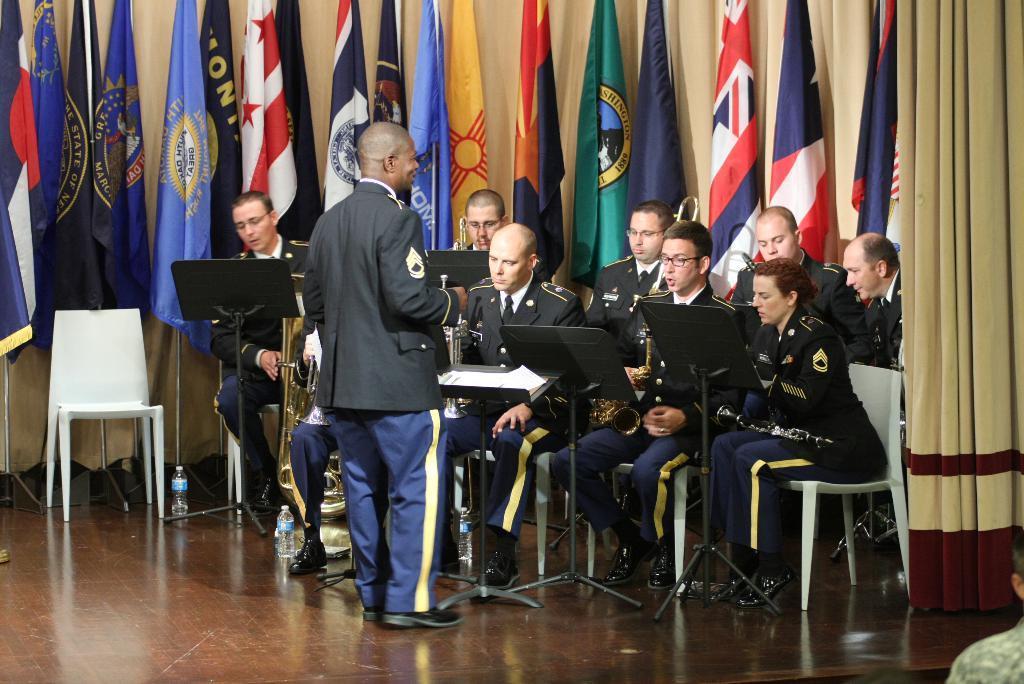Could you give a brief overview of what you see in this image? In the picture I can see a group of people sitting on the chairs and they are holding the musical instruments. I can see a man standing on the floor. In the background, I can see the curtain and flagpoles. I can see the water bottles on the floor. 